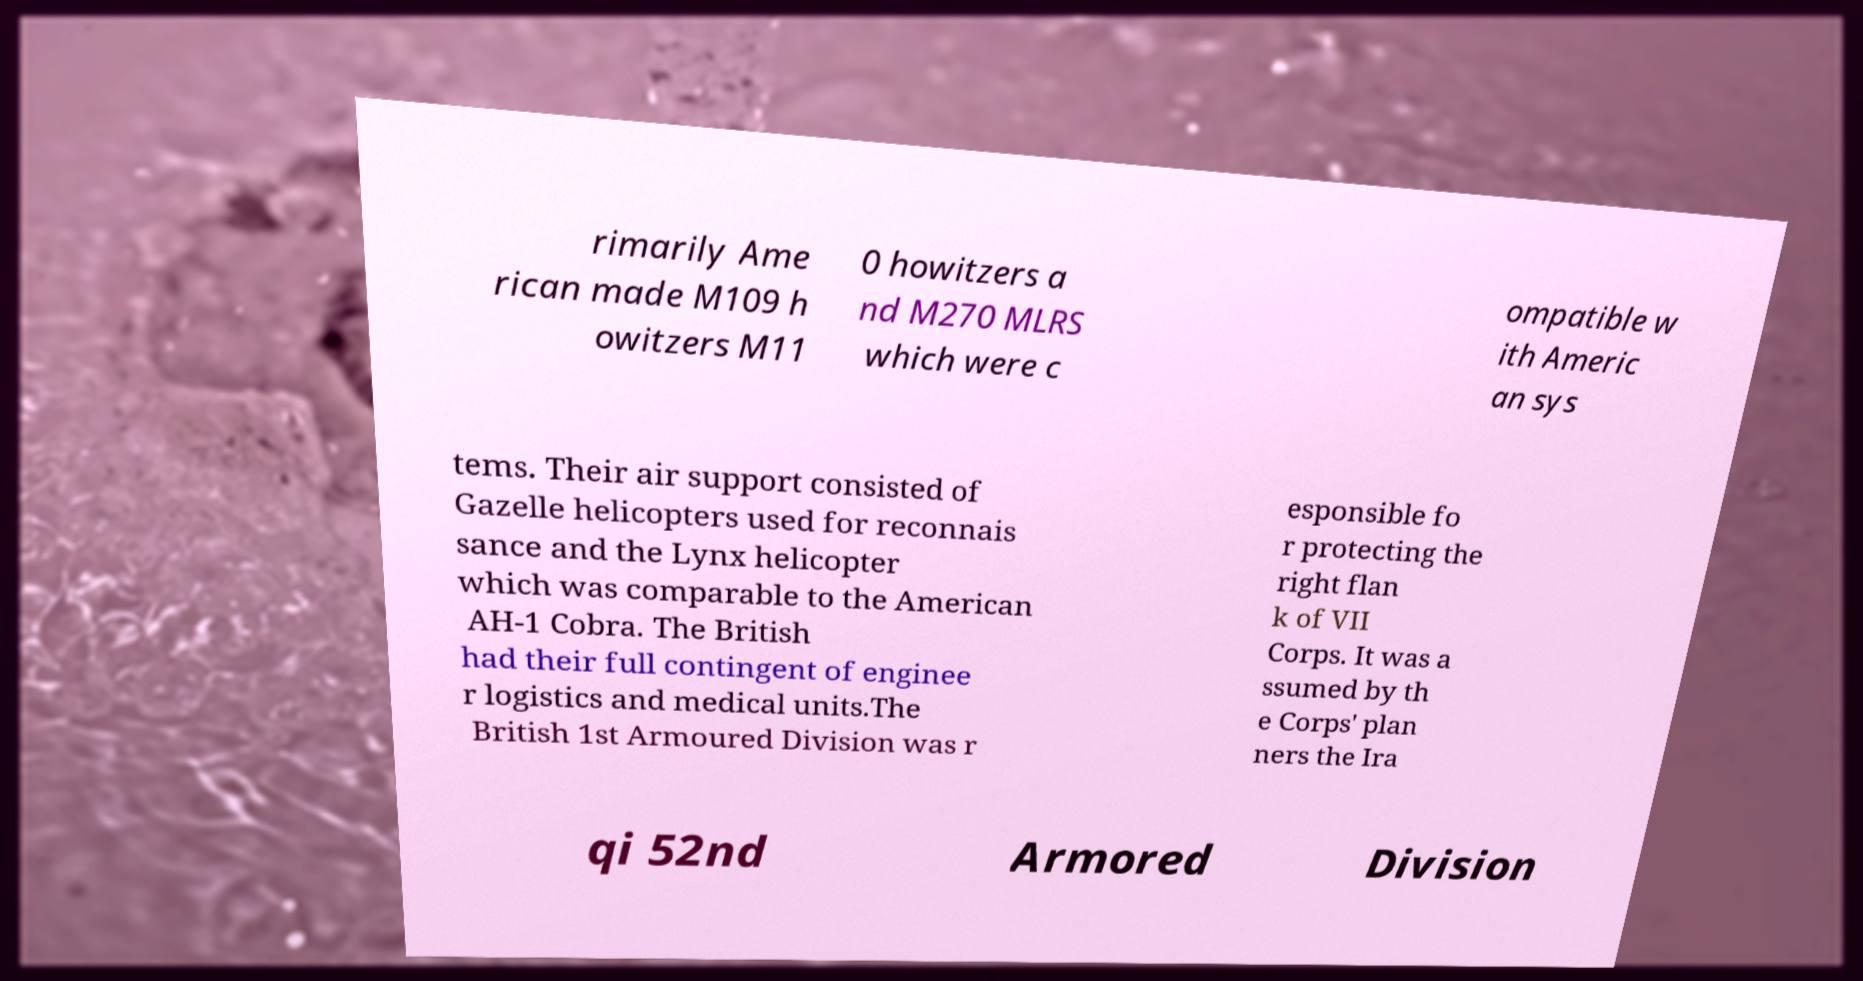What messages or text are displayed in this image? I need them in a readable, typed format. rimarily Ame rican made M109 h owitzers M11 0 howitzers a nd M270 MLRS which were c ompatible w ith Americ an sys tems. Their air support consisted of Gazelle helicopters used for reconnais sance and the Lynx helicopter which was comparable to the American AH-1 Cobra. The British had their full contingent of enginee r logistics and medical units.The British 1st Armoured Division was r esponsible fo r protecting the right flan k of VII Corps. It was a ssumed by th e Corps' plan ners the Ira qi 52nd Armored Division 